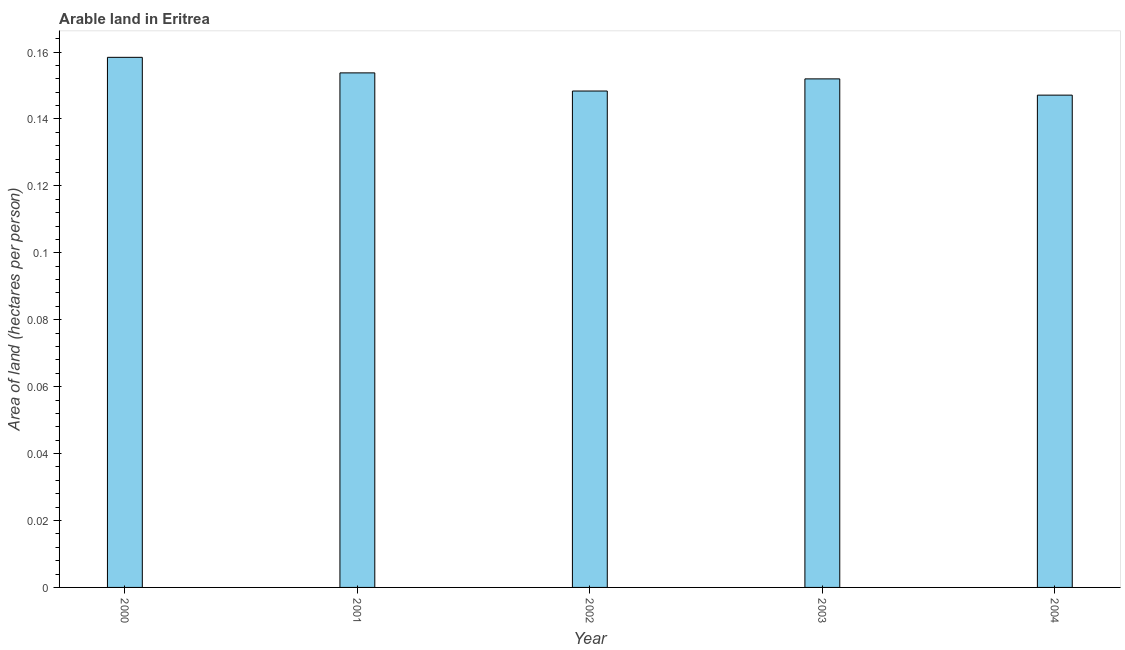What is the title of the graph?
Your answer should be compact. Arable land in Eritrea. What is the label or title of the Y-axis?
Make the answer very short. Area of land (hectares per person). What is the area of arable land in 2003?
Offer a terse response. 0.15. Across all years, what is the maximum area of arable land?
Provide a succinct answer. 0.16. Across all years, what is the minimum area of arable land?
Offer a terse response. 0.15. In which year was the area of arable land minimum?
Offer a terse response. 2004. What is the sum of the area of arable land?
Provide a succinct answer. 0.76. What is the difference between the area of arable land in 2000 and 2004?
Offer a very short reply. 0.01. What is the average area of arable land per year?
Make the answer very short. 0.15. What is the median area of arable land?
Ensure brevity in your answer.  0.15. Do a majority of the years between 2002 and 2001 (inclusive) have area of arable land greater than 0.008 hectares per person?
Provide a succinct answer. No. What is the ratio of the area of arable land in 2001 to that in 2002?
Provide a succinct answer. 1.04. Is the difference between the area of arable land in 2000 and 2004 greater than the difference between any two years?
Your response must be concise. Yes. What is the difference between the highest and the second highest area of arable land?
Make the answer very short. 0.01. Is the sum of the area of arable land in 2001 and 2002 greater than the maximum area of arable land across all years?
Give a very brief answer. Yes. How many bars are there?
Ensure brevity in your answer.  5. Are all the bars in the graph horizontal?
Your answer should be compact. No. What is the difference between two consecutive major ticks on the Y-axis?
Your answer should be very brief. 0.02. What is the Area of land (hectares per person) of 2000?
Your answer should be very brief. 0.16. What is the Area of land (hectares per person) in 2001?
Give a very brief answer. 0.15. What is the Area of land (hectares per person) of 2002?
Ensure brevity in your answer.  0.15. What is the Area of land (hectares per person) in 2003?
Give a very brief answer. 0.15. What is the Area of land (hectares per person) of 2004?
Your answer should be compact. 0.15. What is the difference between the Area of land (hectares per person) in 2000 and 2001?
Your response must be concise. 0. What is the difference between the Area of land (hectares per person) in 2000 and 2002?
Your answer should be very brief. 0.01. What is the difference between the Area of land (hectares per person) in 2000 and 2003?
Make the answer very short. 0.01. What is the difference between the Area of land (hectares per person) in 2000 and 2004?
Provide a short and direct response. 0.01. What is the difference between the Area of land (hectares per person) in 2001 and 2002?
Offer a terse response. 0.01. What is the difference between the Area of land (hectares per person) in 2001 and 2003?
Provide a short and direct response. 0. What is the difference between the Area of land (hectares per person) in 2001 and 2004?
Your answer should be compact. 0.01. What is the difference between the Area of land (hectares per person) in 2002 and 2003?
Give a very brief answer. -0. What is the difference between the Area of land (hectares per person) in 2002 and 2004?
Give a very brief answer. 0. What is the difference between the Area of land (hectares per person) in 2003 and 2004?
Provide a succinct answer. 0. What is the ratio of the Area of land (hectares per person) in 2000 to that in 2002?
Give a very brief answer. 1.07. What is the ratio of the Area of land (hectares per person) in 2000 to that in 2003?
Your answer should be compact. 1.04. What is the ratio of the Area of land (hectares per person) in 2000 to that in 2004?
Give a very brief answer. 1.08. What is the ratio of the Area of land (hectares per person) in 2001 to that in 2003?
Your answer should be compact. 1.01. What is the ratio of the Area of land (hectares per person) in 2001 to that in 2004?
Offer a terse response. 1.04. What is the ratio of the Area of land (hectares per person) in 2003 to that in 2004?
Keep it short and to the point. 1.03. 